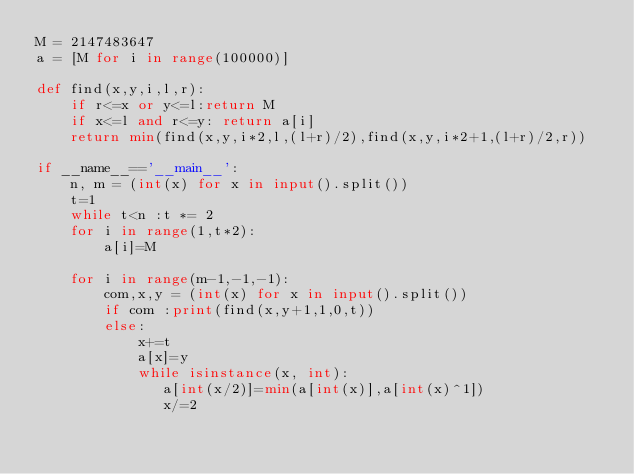<code> <loc_0><loc_0><loc_500><loc_500><_Python_>M = 2147483647
a = [M for i in range(100000)]

def find(x,y,i,l,r):
    if r<=x or y<=l:return M
    if x<=l and r<=y: return a[i]
    return min(find(x,y,i*2,l,(l+r)/2),find(x,y,i*2+1,(l+r)/2,r))

if __name__=='__main__':
    n, m = (int(x) for x in input().split())
    t=1
    while t<n :t *= 2
    for i in range(1,t*2):
        a[i]=M

    for i in range(m-1,-1,-1):
        com,x,y = (int(x) for x in input().split())
        if com :print(find(x,y+1,1,0,t))
        else:
            x+=t
            a[x]=y
            while isinstance(x, int):
               a[int(x/2)]=min(a[int(x)],a[int(x)^1])
               x/=2

</code> 